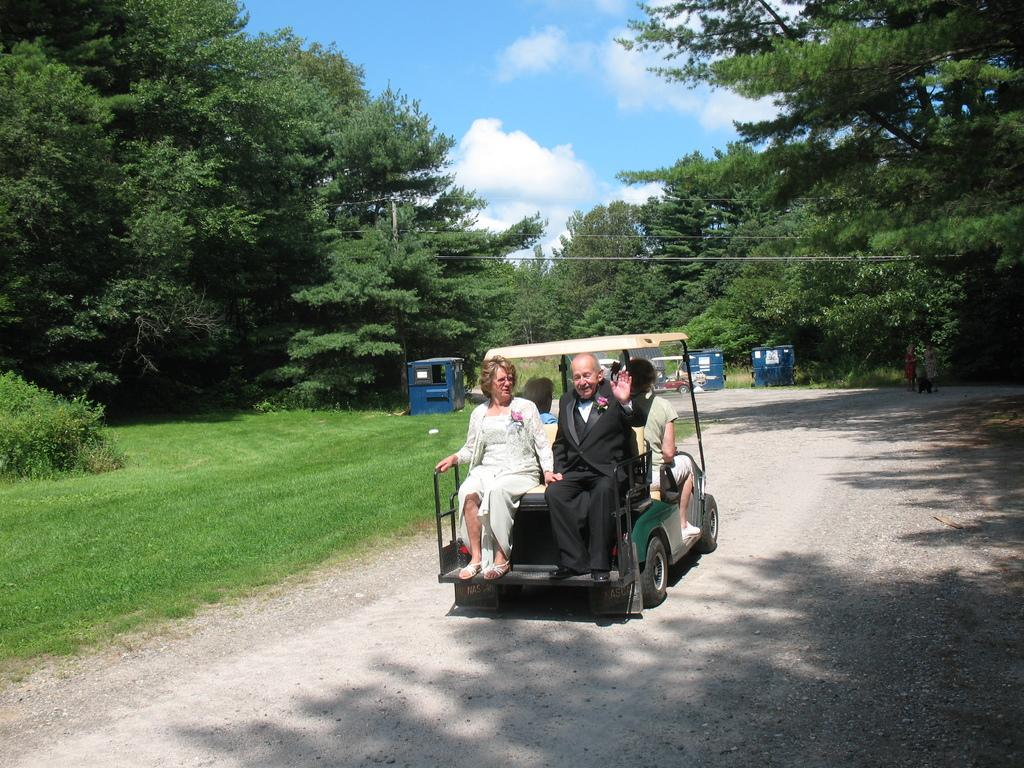Who can be seen in the image? There is a man and a woman in the image. What are they doing in the image? They are sitting on a vehicle. What is the vehicle doing in the image? The vehicle is travelling on a road. What can be seen on the left side of the image? There are green trees on the left side of the image. What is the color of the sky in the image? The sky is blue in the image. What type of soda is the man drinking in the image? There is no soda present in the image; the man and woman are sitting on a vehicle. What color are the woman's trousers in the image? The image does not show the woman's trousers, so we cannot determine their color. 